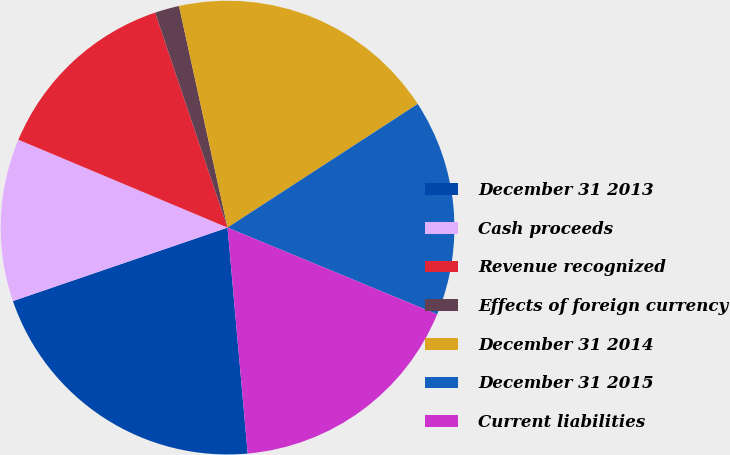Convert chart. <chart><loc_0><loc_0><loc_500><loc_500><pie_chart><fcel>December 31 2013<fcel>Cash proceeds<fcel>Revenue recognized<fcel>Effects of foreign currency<fcel>December 31 2014<fcel>December 31 2015<fcel>Current liabilities<nl><fcel>21.17%<fcel>11.58%<fcel>13.5%<fcel>1.74%<fcel>19.26%<fcel>15.42%<fcel>17.34%<nl></chart> 